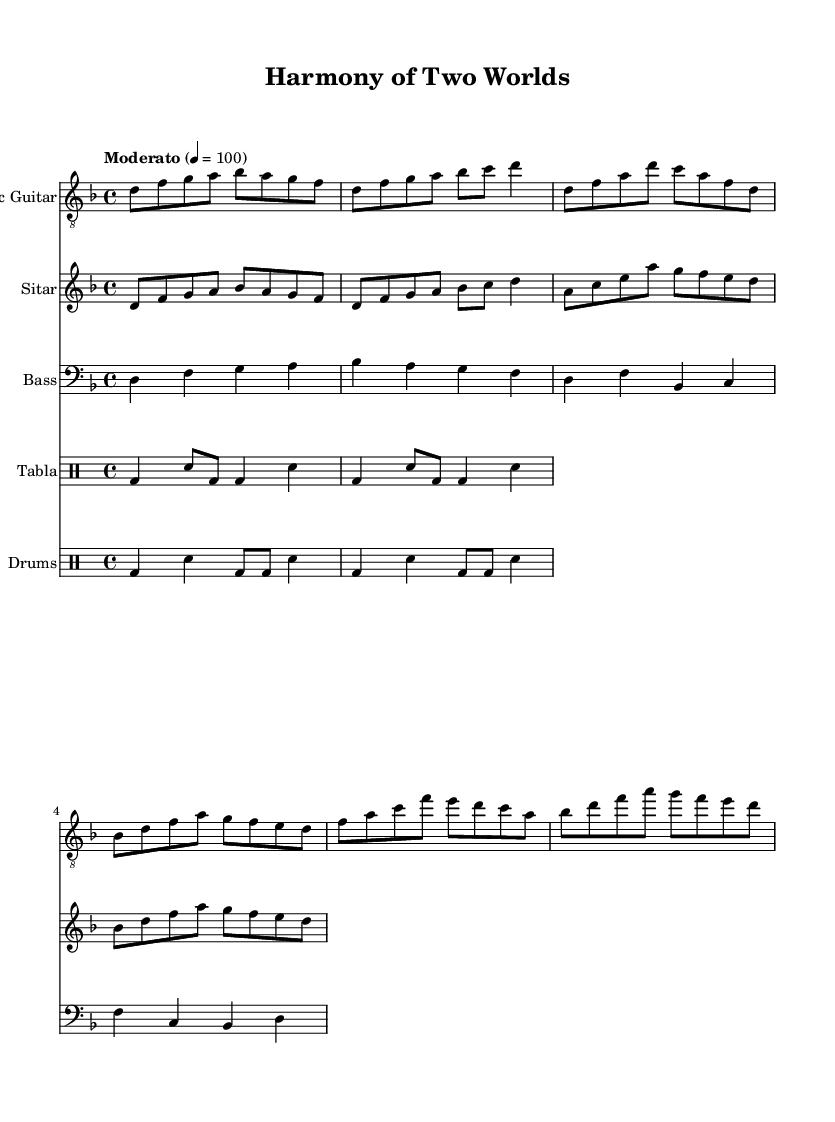What is the key signature of this music? The key signature is D minor, indicated at the beginning of the score where there are one flat (B flat) shown in the key signature section.
Answer: D minor What is the time signature of this music? The time signature is 4/4, noted at the beginning where it displays the structure of four beats per measure.
Answer: 4/4 What is the tempo marking for this piece? The tempo marking indicates a moderate pace of 100 beats per minute, listed under the tempo instruction at the start of the score.
Answer: Moderato 4 = 100 Which instruments are included in this piece? The instruments listed in the score are Electric Guitar, Sitar, Bass, Tabla, and Drums, detailed in the respective staff headers.
Answer: Electric Guitar, Sitar, Bass, Tabla, Drums What type of rhythmic pattern is used for the tabla? The score shows a basic tabla pattern with a series of bass drum (bd) and snare (sn) notes in a specified sequence.
Answer: Basic tabla pattern How does the verse differ from the chorus in terms of notes used? The verse emphasizes different notes (D, F, A, D, C, A, F, D) compared to the chorus which contains a repeated melodic structure (F, A, C, F, E, D, C, A). This showcases a contrast between the two sections.
Answer: Different notes What influences the fusion in this piece? The piece blends Eastern influences through the sitar with Western rock elements evident in the electric guitar and rhythm, showcasing a cross-cultural combination.
Answer: Eastern and Western influences 